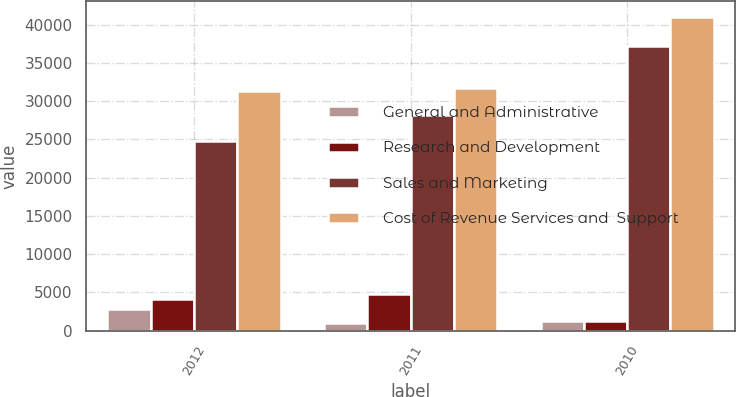Convert chart to OTSL. <chart><loc_0><loc_0><loc_500><loc_500><stacked_bar_chart><ecel><fcel>2012<fcel>2011<fcel>2010<nl><fcel>General and Administrative<fcel>2840<fcel>936<fcel>1265<nl><fcel>Research and Development<fcel>4130<fcel>4716<fcel>1251<nl><fcel>Sales and Marketing<fcel>24823<fcel>28132<fcel>37221<nl><fcel>Cost of Revenue Services and  Support<fcel>31379<fcel>31754<fcel>40983<nl></chart> 